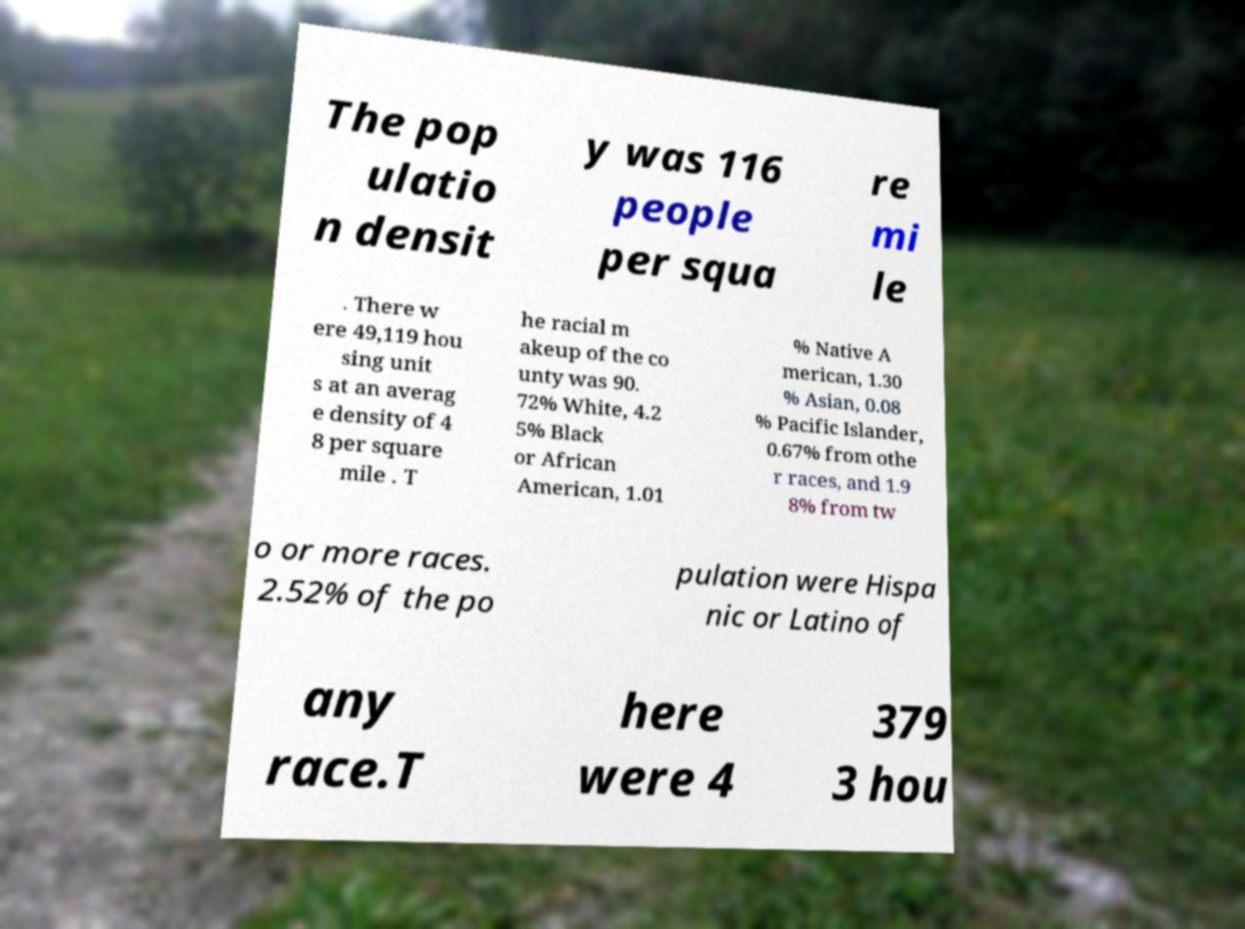There's text embedded in this image that I need extracted. Can you transcribe it verbatim? The pop ulatio n densit y was 116 people per squa re mi le . There w ere 49,119 hou sing unit s at an averag e density of 4 8 per square mile . T he racial m akeup of the co unty was 90. 72% White, 4.2 5% Black or African American, 1.01 % Native A merican, 1.30 % Asian, 0.08 % Pacific Islander, 0.67% from othe r races, and 1.9 8% from tw o or more races. 2.52% of the po pulation were Hispa nic or Latino of any race.T here were 4 379 3 hou 